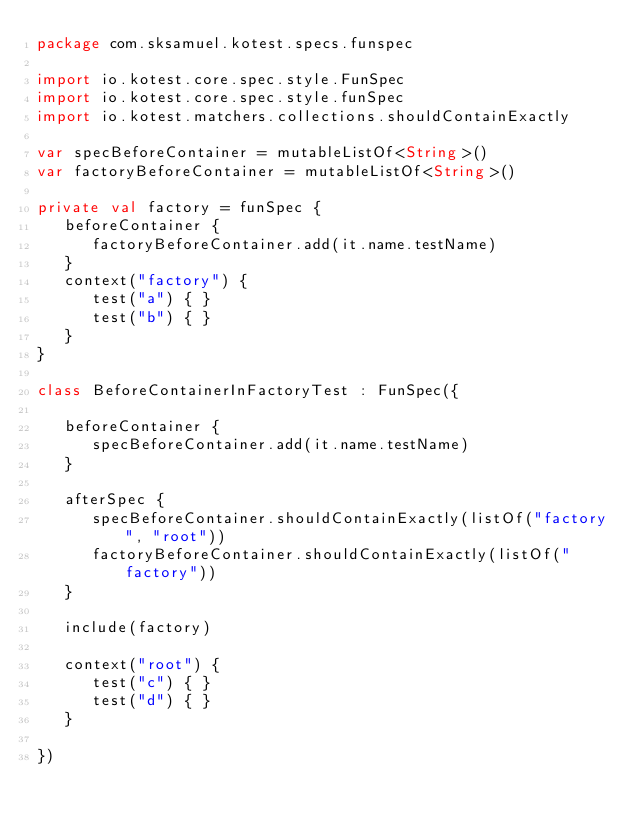<code> <loc_0><loc_0><loc_500><loc_500><_Kotlin_>package com.sksamuel.kotest.specs.funspec

import io.kotest.core.spec.style.FunSpec
import io.kotest.core.spec.style.funSpec
import io.kotest.matchers.collections.shouldContainExactly

var specBeforeContainer = mutableListOf<String>()
var factoryBeforeContainer = mutableListOf<String>()

private val factory = funSpec {
   beforeContainer {
      factoryBeforeContainer.add(it.name.testName)
   }
   context("factory") {
      test("a") { }
      test("b") { }
   }
}

class BeforeContainerInFactoryTest : FunSpec({

   beforeContainer {
      specBeforeContainer.add(it.name.testName)
   }

   afterSpec {
      specBeforeContainer.shouldContainExactly(listOf("factory", "root"))
      factoryBeforeContainer.shouldContainExactly(listOf("factory"))
   }

   include(factory)

   context("root") {
      test("c") { }
      test("d") { }
   }

})
</code> 